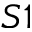Convert formula to latex. <formula><loc_0><loc_0><loc_500><loc_500>S 1</formula> 